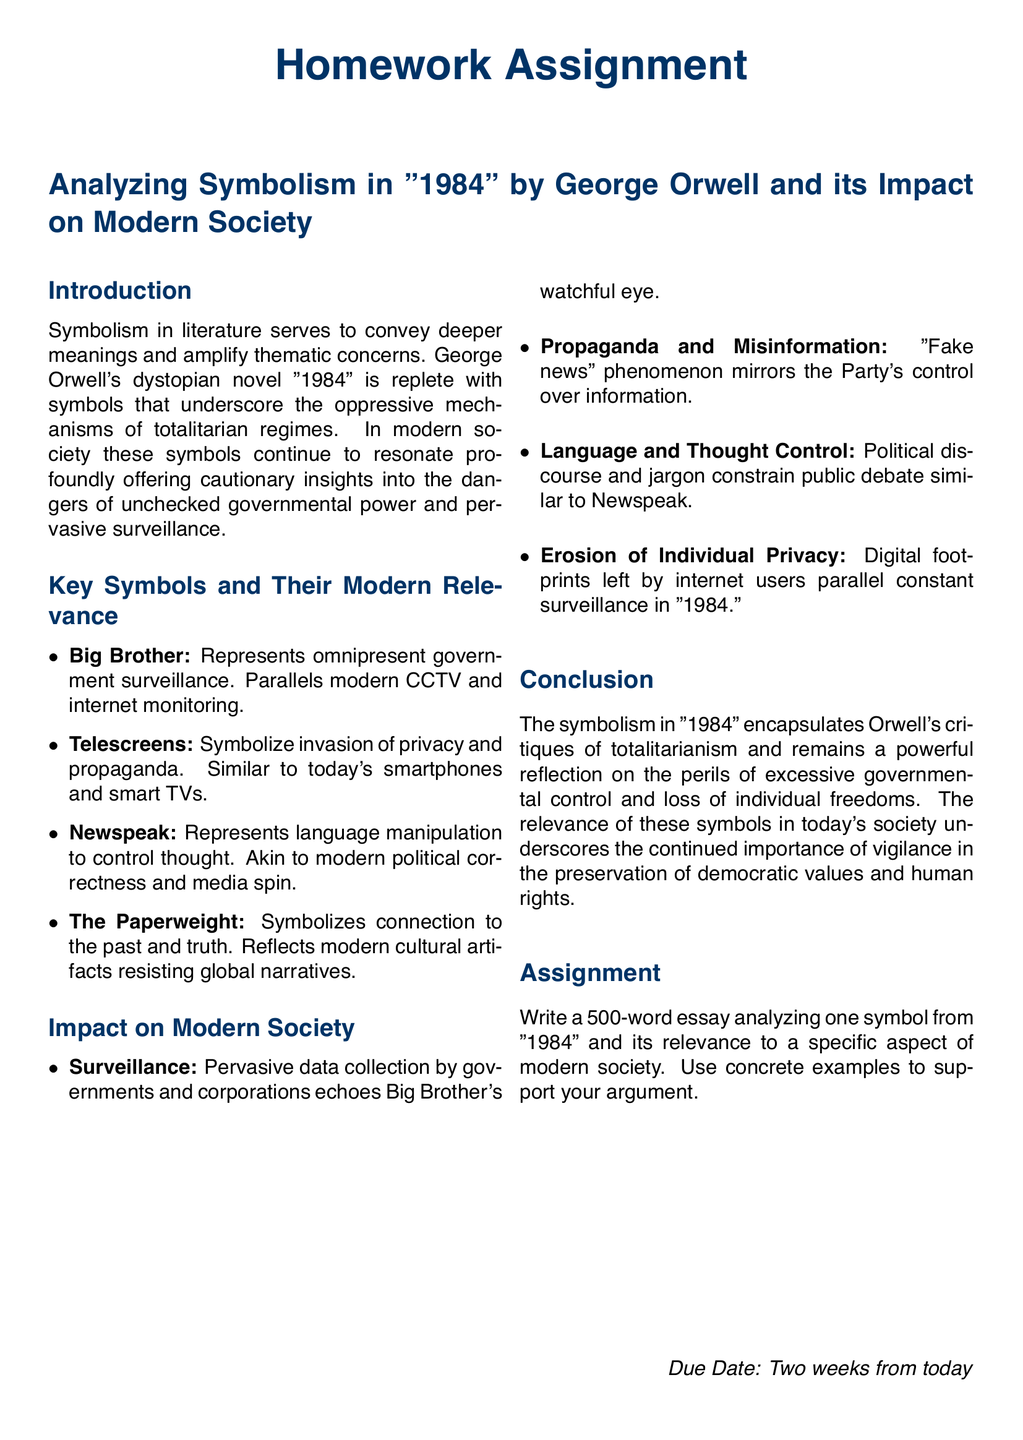What is the title of the homework assignment? The title is stated prominently at the beginning of the document as the main topic of the assignment.
Answer: Analyzing Symbolism in "1984" by George Orwell and its Impact on Modern Society What is the due date for the homework? The due date is specified at the end of the document, indicating when the assignment should be submitted.
Answer: Two weeks from today What is one of the key symbols mentioned in the document? The document lists various symbols in the section dedicated to key symbols related to the novel.
Answer: Big Brother What does the symbol "Telescreens" represent? The document provides a brief explanation of what the symbol signifies in relation to modern technology and privacy.
Answer: Invasion of privacy and propaganda How many words should the essay contain? This information is provided in the assignment section, which specifies the length requirement for the essay.
Answer: 500 words What is the significance of the "Paperweight" symbol? The document includes a description of the symbolism, identifying its connection to broader themes in the novel and modern society.
Answer: Connection to the past and truth Which symbol parallels modern political correctness? The document explains how language manipulation in the novel relates to current societal issues.
Answer: Newspeak What kind of societal issues are discussed in relation to these symbols? The document highlights various modern concerns that resonate with the themes in "1984."
Answer: Surveillance, propaganda, thought control, privacy What literary work is the focus of this homework assignment? The title and subsequent content identify the specific literary work being analyzed in this assignment.
Answer: "1984" 